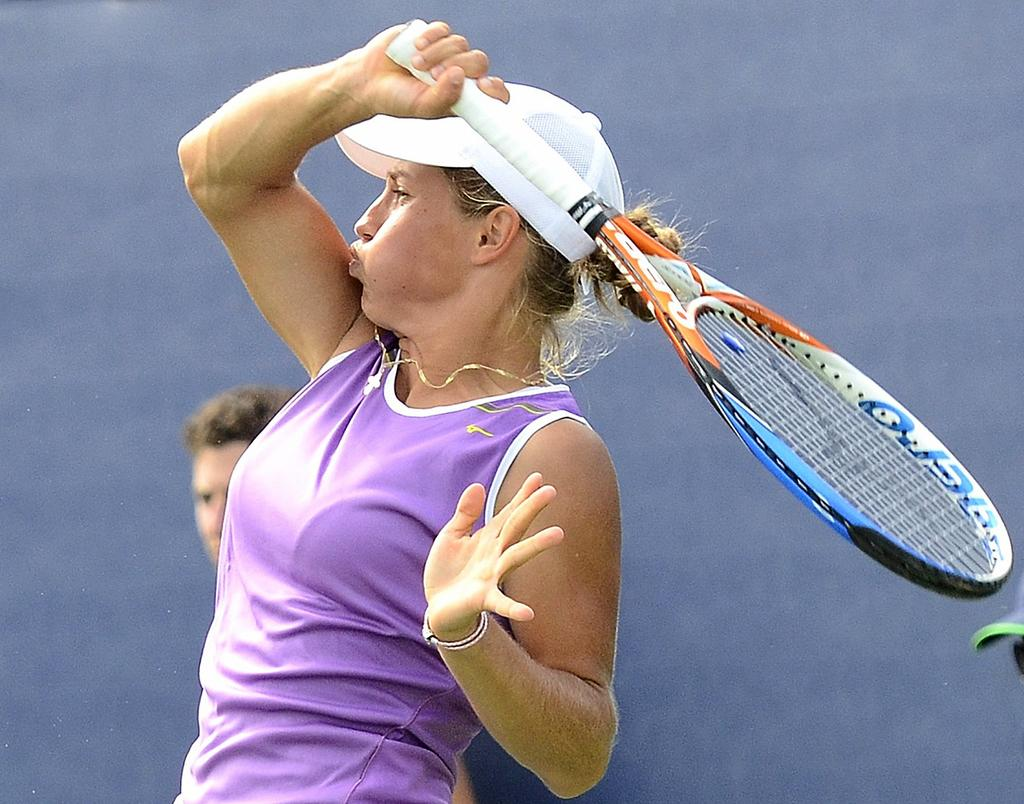What is the woman in the image doing? The woman is playing badminton in the image. What is the woman wearing while playing badminton? The woman is wearing a purple dress and a white cap on her head. What is the boy in the image doing? The boy is standing and watching the game in the image. What type of turkey can be seen in the image? There is no turkey present in the image. How does the badminton game affect the acoustics in the image? The provided facts do not mention anything about the acoustics in the image, so it cannot be determined how the badminton game affects them. 